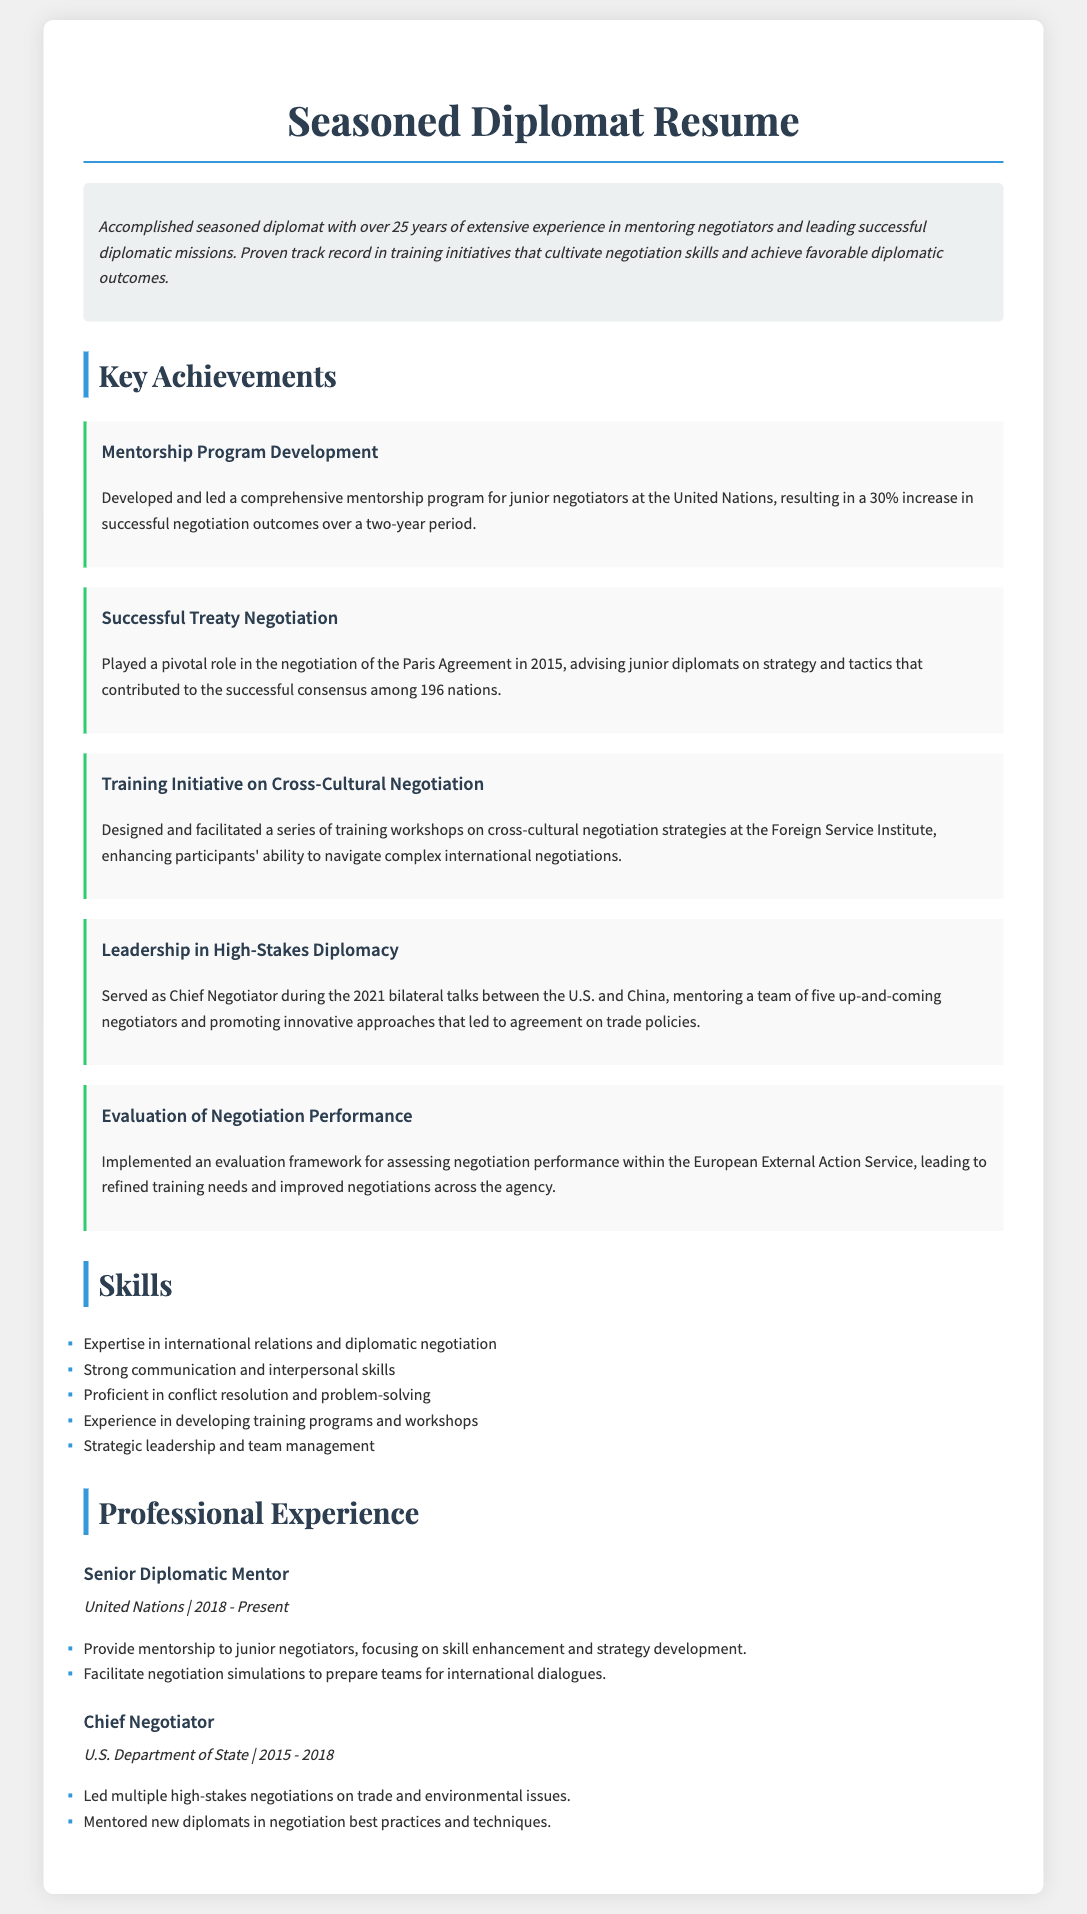what is the role of the individual at the United Nations? The individual is a Senior Diplomatic Mentor, responsible for mentoring junior negotiators.
Answer: Senior Diplomatic Mentor what was the impact of the mentorship program developed? The mentorship program resulted in a 30% increase in successful negotiation outcomes over a two-year period.
Answer: 30% what major international agreement did the individual contribute to? The individual played a role in negotiating the Paris Agreement.
Answer: Paris Agreement what year did the individual serve as Chief Negotiator for the U.S. Department of State? The individual served as Chief Negotiator between the years 2015 and 2018.
Answer: 2015 - 2018 how many junior negotiators were mentored during the bilateral talks in 2021? The individual mentored a team of five up-and-coming negotiators during these talks.
Answer: five what type of training workshops did the individual design? The individual designed training workshops focused on cross-cultural negotiation strategies.
Answer: cross-cultural negotiation strategies what is one key leadership role held by the individual? The individual served as the Chief Negotiator during bilateral talks.
Answer: Chief Negotiator how long is the individual's experience in diplomacy? The individual has over 25 years of extensive experience in diplomacy.
Answer: over 25 years what framework did the individual implement within the European External Action Service? The individual implemented an evaluation framework for assessing negotiation performance.
Answer: evaluation framework 